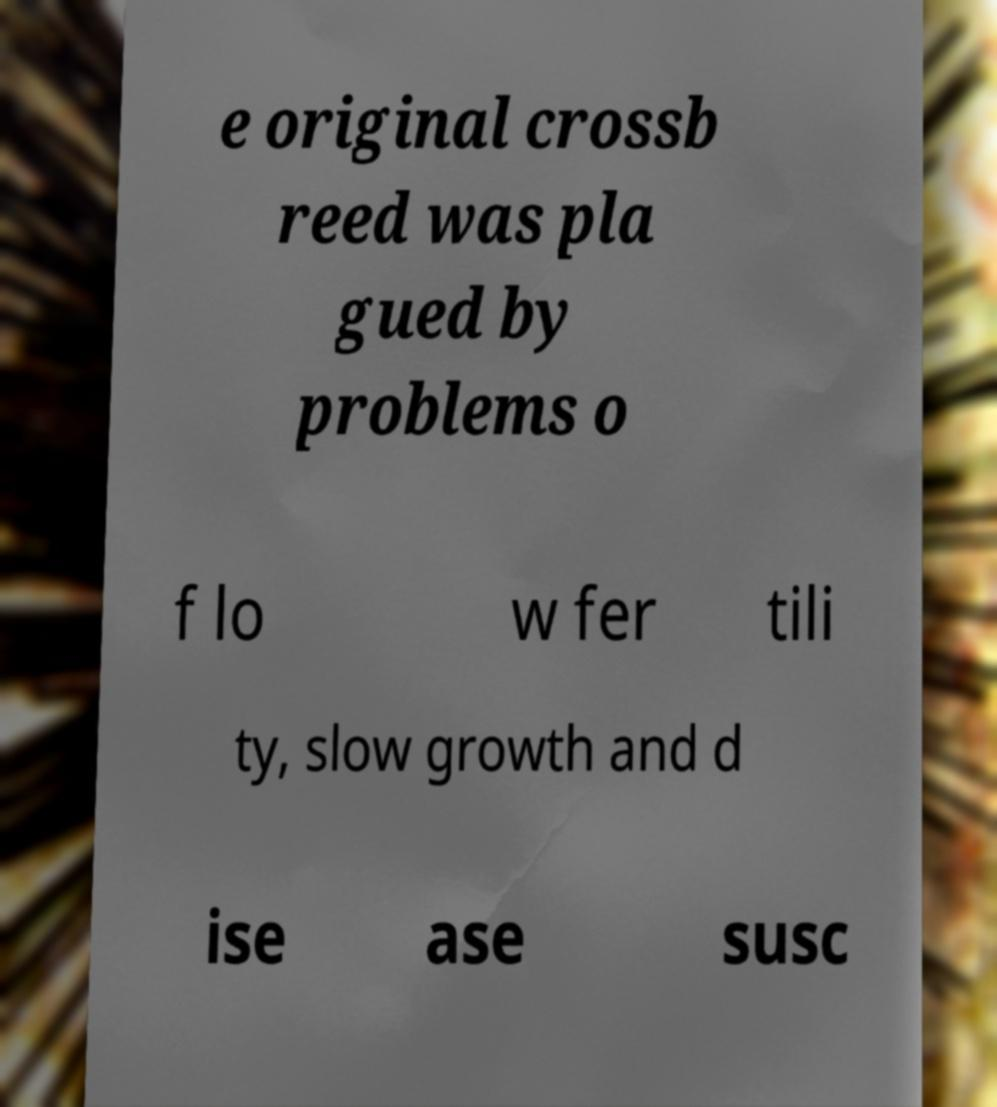I need the written content from this picture converted into text. Can you do that? e original crossb reed was pla gued by problems o f lo w fer tili ty, slow growth and d ise ase susc 